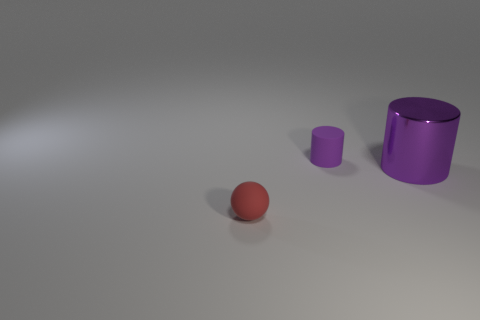Add 3 tiny red cylinders. How many objects exist? 6 Subtract all spheres. How many objects are left? 2 Add 3 red objects. How many red objects are left? 4 Add 3 tiny green rubber objects. How many tiny green rubber objects exist? 3 Subtract 0 cyan blocks. How many objects are left? 3 Subtract all small purple objects. Subtract all shiny things. How many objects are left? 1 